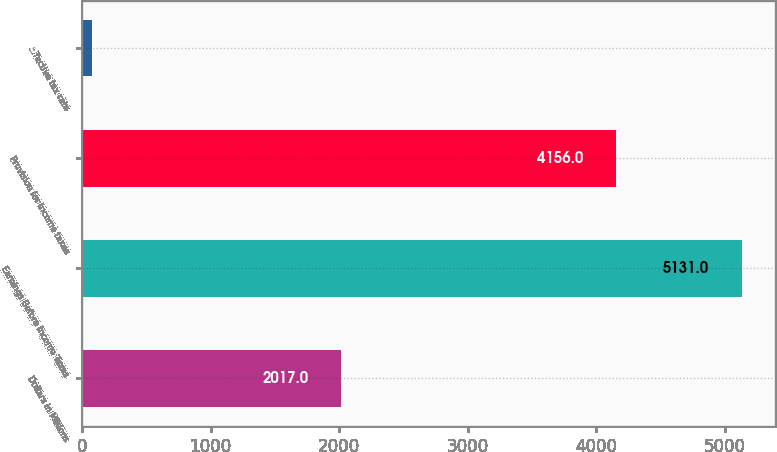Convert chart. <chart><loc_0><loc_0><loc_500><loc_500><bar_chart><fcel>Dollars in Millions<fcel>Earnings Before Income Taxes<fcel>Provision for income taxes<fcel>Effective tax rate<nl><fcel>2017<fcel>5131<fcel>4156<fcel>81<nl></chart> 